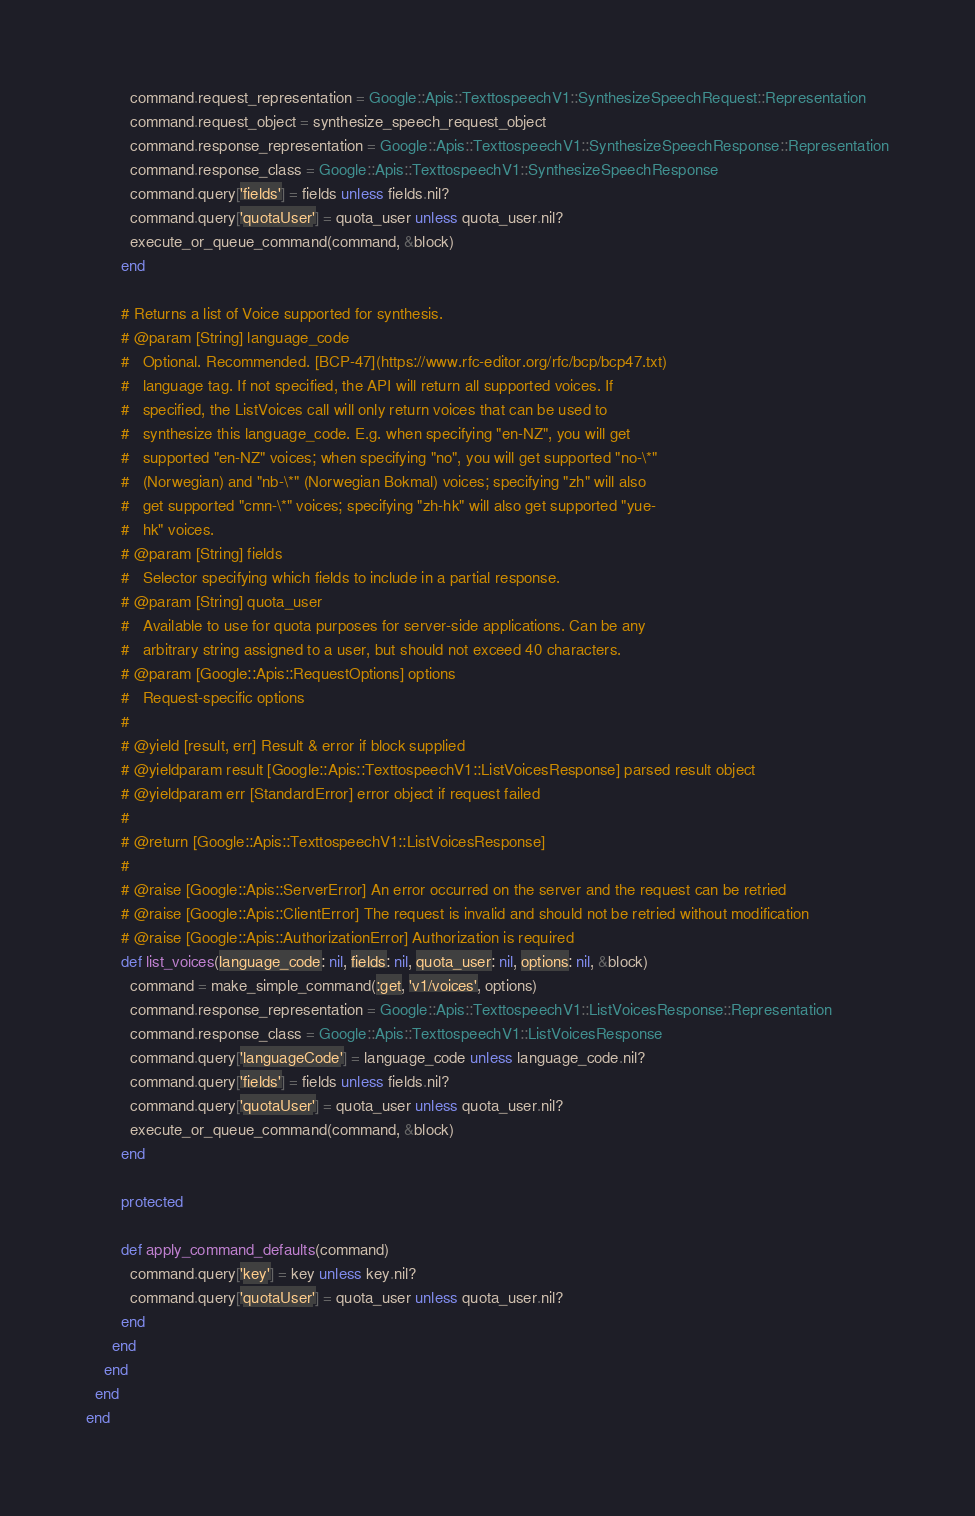<code> <loc_0><loc_0><loc_500><loc_500><_Ruby_>          command.request_representation = Google::Apis::TexttospeechV1::SynthesizeSpeechRequest::Representation
          command.request_object = synthesize_speech_request_object
          command.response_representation = Google::Apis::TexttospeechV1::SynthesizeSpeechResponse::Representation
          command.response_class = Google::Apis::TexttospeechV1::SynthesizeSpeechResponse
          command.query['fields'] = fields unless fields.nil?
          command.query['quotaUser'] = quota_user unless quota_user.nil?
          execute_or_queue_command(command, &block)
        end
        
        # Returns a list of Voice supported for synthesis.
        # @param [String] language_code
        #   Optional. Recommended. [BCP-47](https://www.rfc-editor.org/rfc/bcp/bcp47.txt)
        #   language tag. If not specified, the API will return all supported voices. If
        #   specified, the ListVoices call will only return voices that can be used to
        #   synthesize this language_code. E.g. when specifying "en-NZ", you will get
        #   supported "en-NZ" voices; when specifying "no", you will get supported "no-\*"
        #   (Norwegian) and "nb-\*" (Norwegian Bokmal) voices; specifying "zh" will also
        #   get supported "cmn-\*" voices; specifying "zh-hk" will also get supported "yue-
        #   hk" voices.
        # @param [String] fields
        #   Selector specifying which fields to include in a partial response.
        # @param [String] quota_user
        #   Available to use for quota purposes for server-side applications. Can be any
        #   arbitrary string assigned to a user, but should not exceed 40 characters.
        # @param [Google::Apis::RequestOptions] options
        #   Request-specific options
        #
        # @yield [result, err] Result & error if block supplied
        # @yieldparam result [Google::Apis::TexttospeechV1::ListVoicesResponse] parsed result object
        # @yieldparam err [StandardError] error object if request failed
        #
        # @return [Google::Apis::TexttospeechV1::ListVoicesResponse]
        #
        # @raise [Google::Apis::ServerError] An error occurred on the server and the request can be retried
        # @raise [Google::Apis::ClientError] The request is invalid and should not be retried without modification
        # @raise [Google::Apis::AuthorizationError] Authorization is required
        def list_voices(language_code: nil, fields: nil, quota_user: nil, options: nil, &block)
          command = make_simple_command(:get, 'v1/voices', options)
          command.response_representation = Google::Apis::TexttospeechV1::ListVoicesResponse::Representation
          command.response_class = Google::Apis::TexttospeechV1::ListVoicesResponse
          command.query['languageCode'] = language_code unless language_code.nil?
          command.query['fields'] = fields unless fields.nil?
          command.query['quotaUser'] = quota_user unless quota_user.nil?
          execute_or_queue_command(command, &block)
        end

        protected

        def apply_command_defaults(command)
          command.query['key'] = key unless key.nil?
          command.query['quotaUser'] = quota_user unless quota_user.nil?
        end
      end
    end
  end
end
</code> 